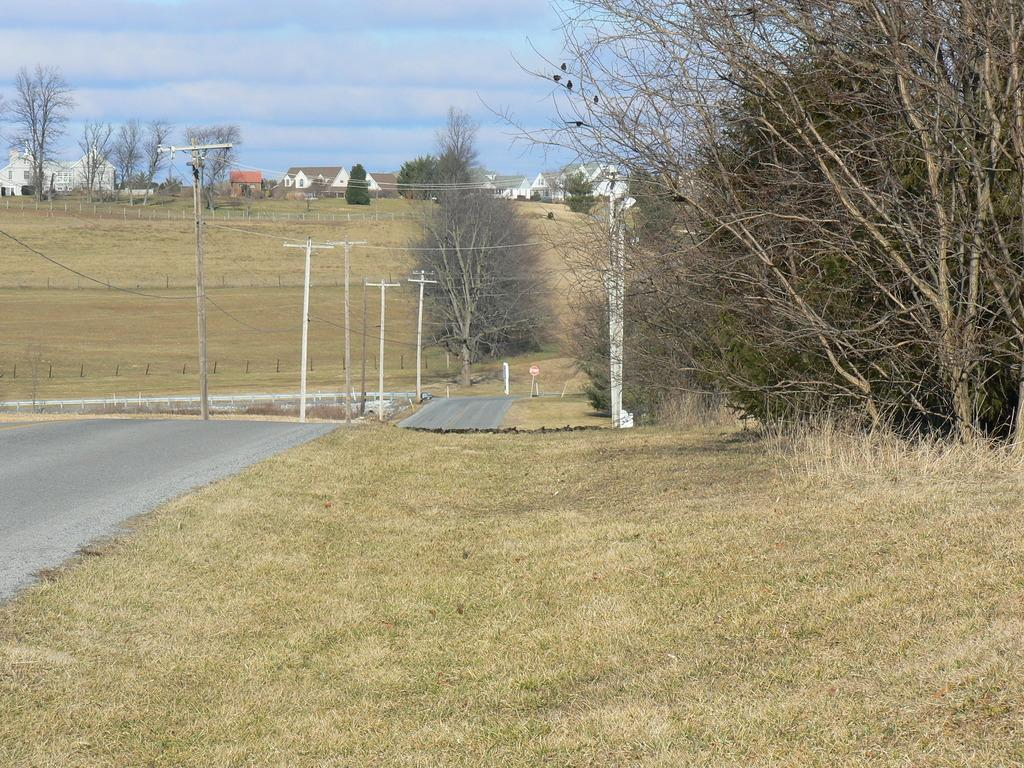What type of vegetation can be seen in the image? There are dry trees and dry grass in the image. What type of structures are visible in the image? There are houses in the image. What type of infrastructure is present in the image? Current poles and wires are visible in the image. What type of signage is present in the image? There is a signboard in the image. What is the color of the sky in the image? The sky is a combination of white and blue colors in the image. Can you tell me how many robins are perched on the dry trees in the image? There are no robins present in the image; it only features dry trees and other elements mentioned in the facts. What type of experience can be gained from observing the image? The image itself does not convey an experience, as it is a static representation of the scene. 